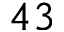<formula> <loc_0><loc_0><loc_500><loc_500>4 3</formula> 